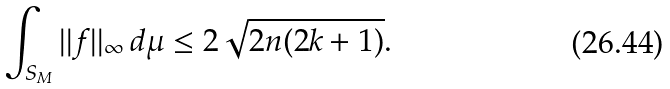Convert formula to latex. <formula><loc_0><loc_0><loc_500><loc_500>\int _ { S _ { M } } | | f | | _ { \infty } \, d \mu \leq 2 \sqrt { 2 n ( 2 k + 1 ) } .</formula> 